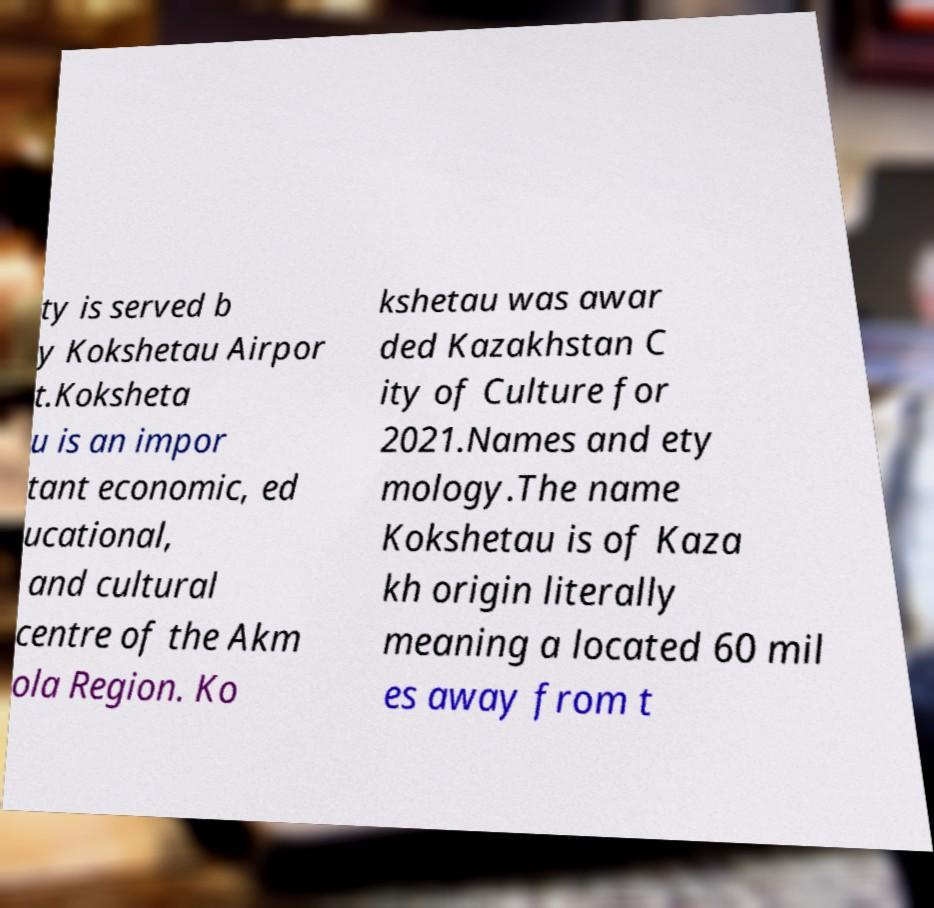Can you accurately transcribe the text from the provided image for me? ty is served b y Kokshetau Airpor t.Koksheta u is an impor tant economic, ed ucational, and cultural centre of the Akm ola Region. Ko kshetau was awar ded Kazakhstan C ity of Culture for 2021.Names and ety mology.The name Kokshetau is of Kaza kh origin literally meaning a located 60 mil es away from t 